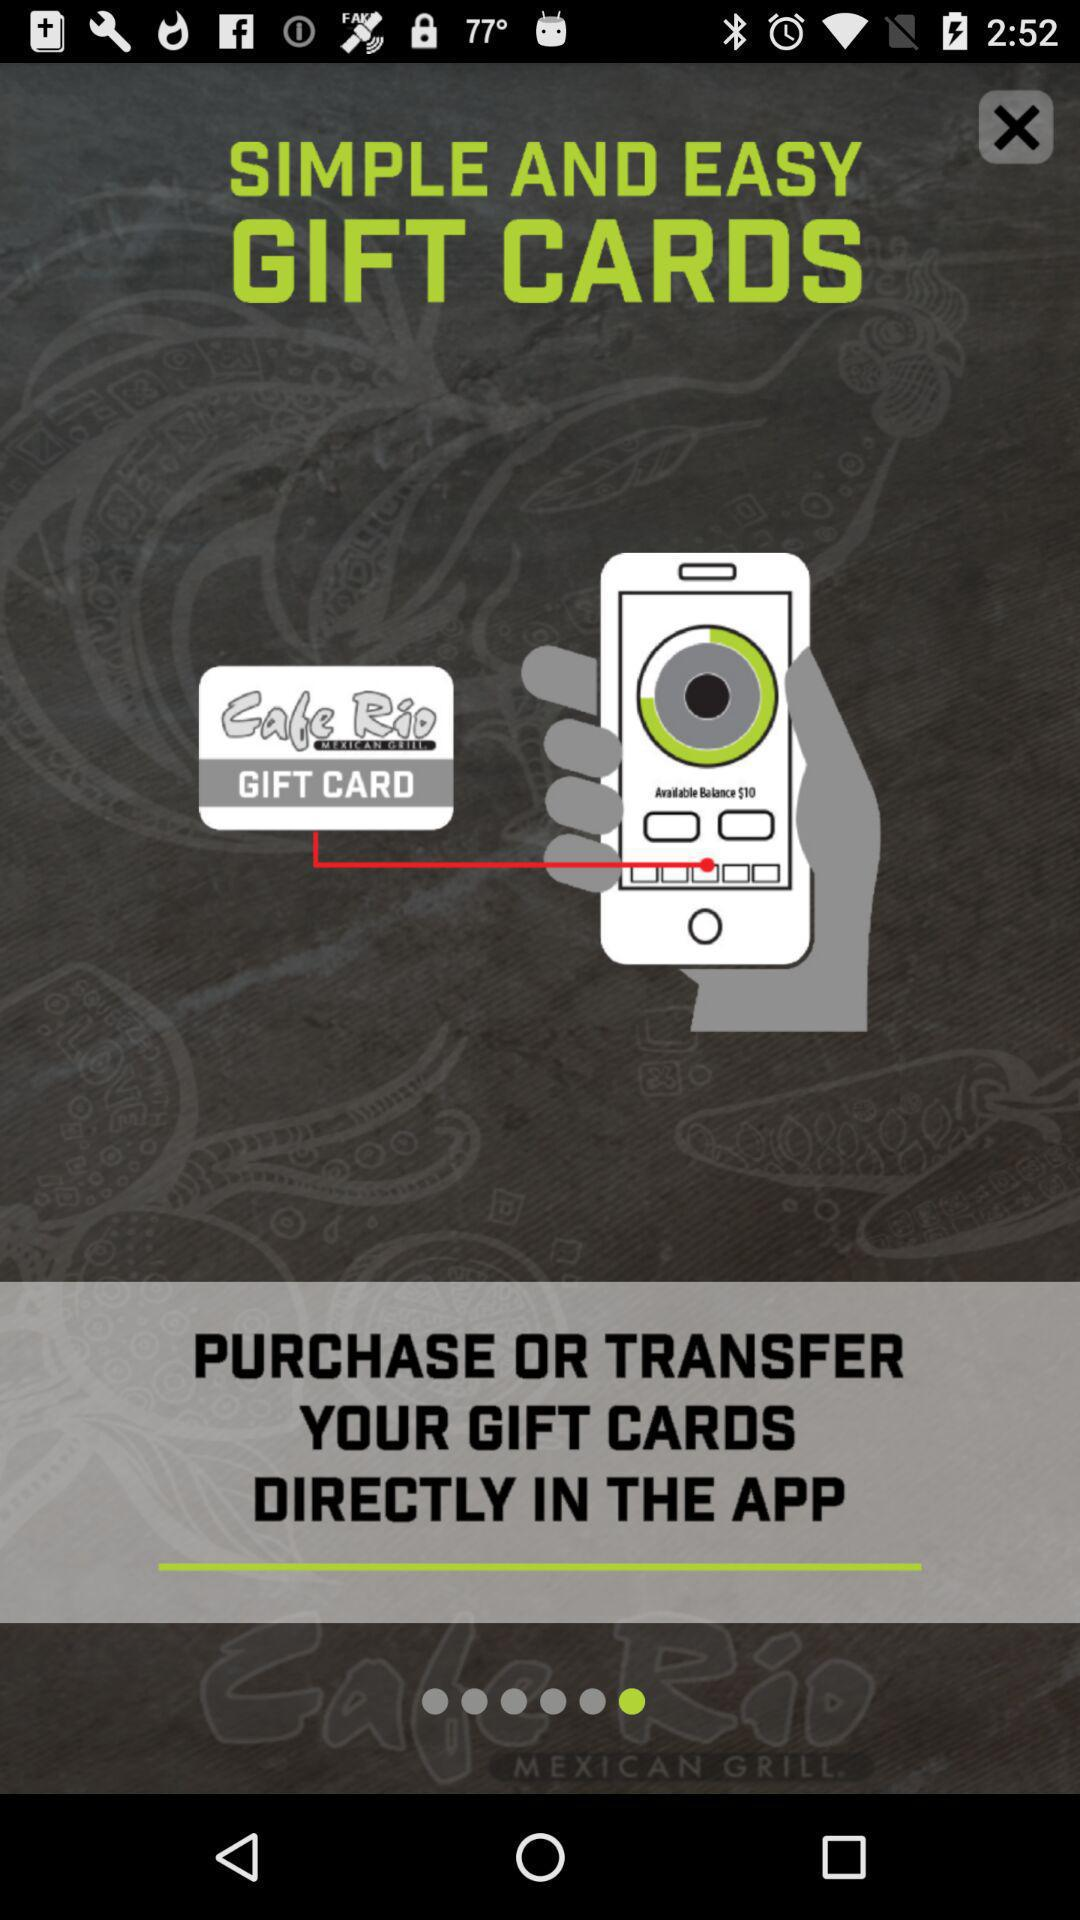What is the application name? The application name is "Cafe Rio". 